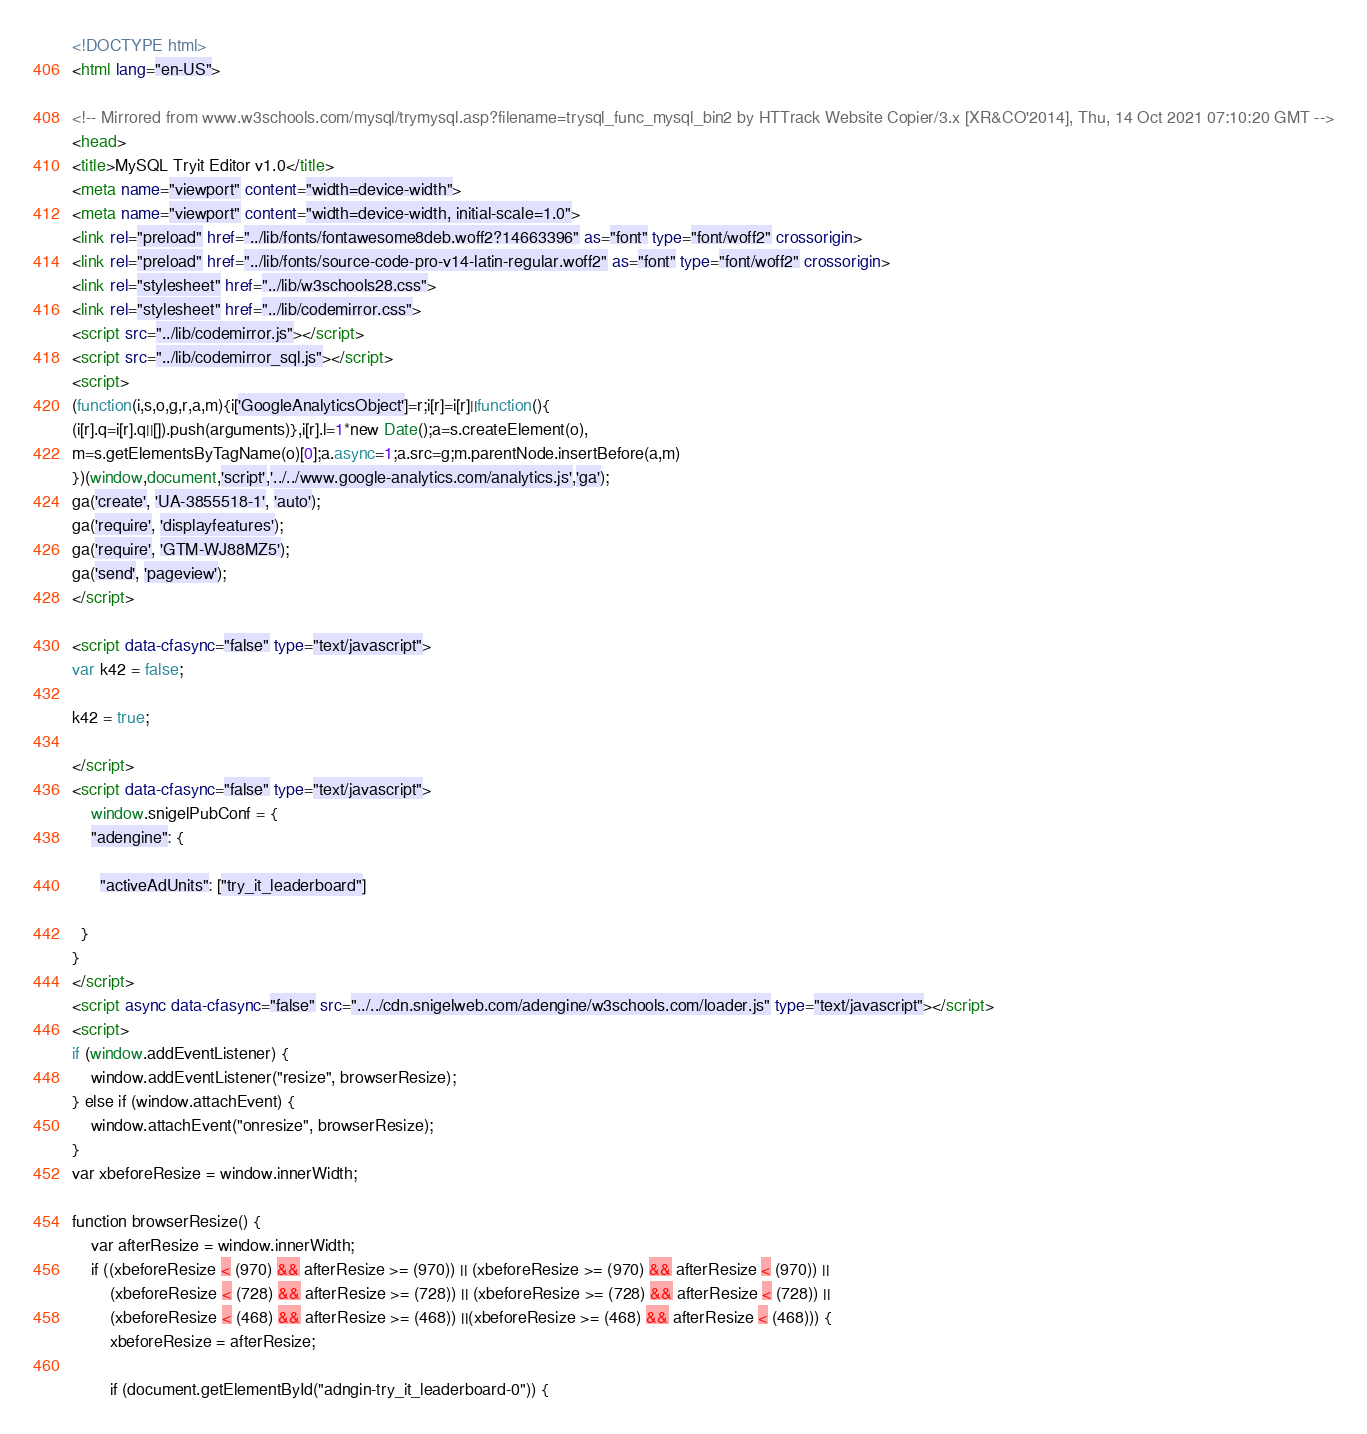Convert code to text. <code><loc_0><loc_0><loc_500><loc_500><_HTML_>
<!DOCTYPE html>
<html lang="en-US">

<!-- Mirrored from www.w3schools.com/mysql/trymysql.asp?filename=trysql_func_mysql_bin2 by HTTrack Website Copier/3.x [XR&CO'2014], Thu, 14 Oct 2021 07:10:20 GMT -->
<head>
<title>MySQL Tryit Editor v1.0</title>
<meta name="viewport" content="width=device-width">
<meta name="viewport" content="width=device-width, initial-scale=1.0">
<link rel="preload" href="../lib/fonts/fontawesome8deb.woff2?14663396" as="font" type="font/woff2" crossorigin> 
<link rel="preload" href="../lib/fonts/source-code-pro-v14-latin-regular.woff2" as="font" type="font/woff2" crossorigin> 
<link rel="stylesheet" href="../lib/w3schools28.css">
<link rel="stylesheet" href="../lib/codemirror.css">
<script src="../lib/codemirror.js"></script>
<script src="../lib/codemirror_sql.js"></script>
<script>
(function(i,s,o,g,r,a,m){i['GoogleAnalyticsObject']=r;i[r]=i[r]||function(){
(i[r].q=i[r].q||[]).push(arguments)},i[r].l=1*new Date();a=s.createElement(o),
m=s.getElementsByTagName(o)[0];a.async=1;a.src=g;m.parentNode.insertBefore(a,m)
})(window,document,'script','../../www.google-analytics.com/analytics.js','ga');
ga('create', 'UA-3855518-1', 'auto');
ga('require', 'displayfeatures');
ga('require', 'GTM-WJ88MZ5');
ga('send', 'pageview');
</script>

<script data-cfasync="false" type="text/javascript">
var k42 = false;

k42 = true;

</script>
<script data-cfasync="false" type="text/javascript">
    window.snigelPubConf = {
    "adengine": {

      "activeAdUnits": ["try_it_leaderboard"]

  }
}
</script>
<script async data-cfasync="false" src="../../cdn.snigelweb.com/adengine/w3schools.com/loader.js" type="text/javascript"></script>
<script>
if (window.addEventListener) {              
    window.addEventListener("resize", browserResize);
} else if (window.attachEvent) {                 
    window.attachEvent("onresize", browserResize);
}
var xbeforeResize = window.innerWidth;

function browserResize() {
    var afterResize = window.innerWidth;
    if ((xbeforeResize < (970) && afterResize >= (970)) || (xbeforeResize >= (970) && afterResize < (970)) ||
        (xbeforeResize < (728) && afterResize >= (728)) || (xbeforeResize >= (728) && afterResize < (728)) ||
        (xbeforeResize < (468) && afterResize >= (468)) ||(xbeforeResize >= (468) && afterResize < (468))) {
        xbeforeResize = afterResize;
        
        if (document.getElementById("adngin-try_it_leaderboard-0")) {</code> 